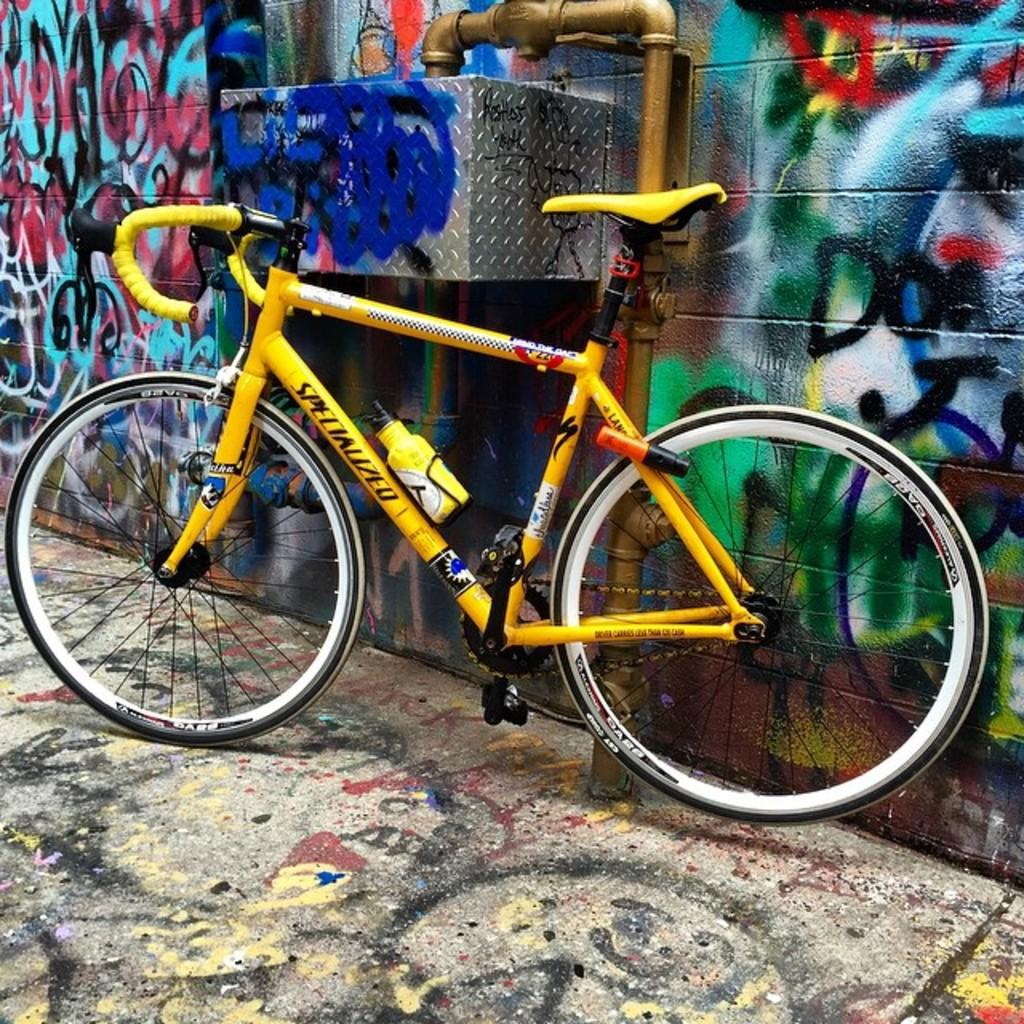What is the main object in the middle of the image? There is a bicycle in the middle of the image. What can be seen in the background of the image? There is a wall in the background of the image. What is visible at the bottom of the image? There is a floor visible at the bottom of the image. How many trucks are parked next to the bicycle in the image? There are no trucks present in the image; it only features a bicycle, a wall in the background, and a floor at the bottom. 